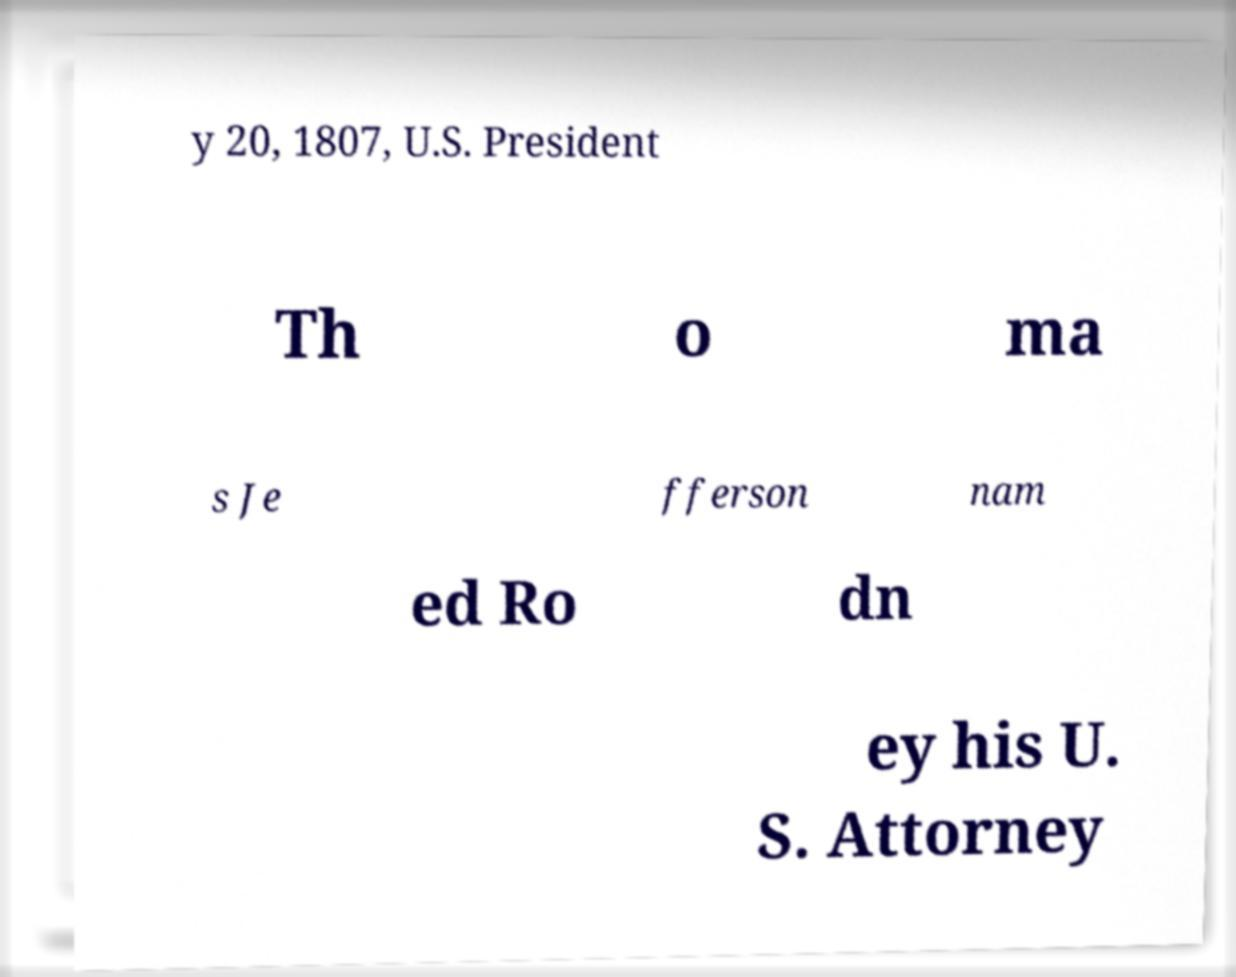Can you accurately transcribe the text from the provided image for me? y 20, 1807, U.S. President Th o ma s Je fferson nam ed Ro dn ey his U. S. Attorney 